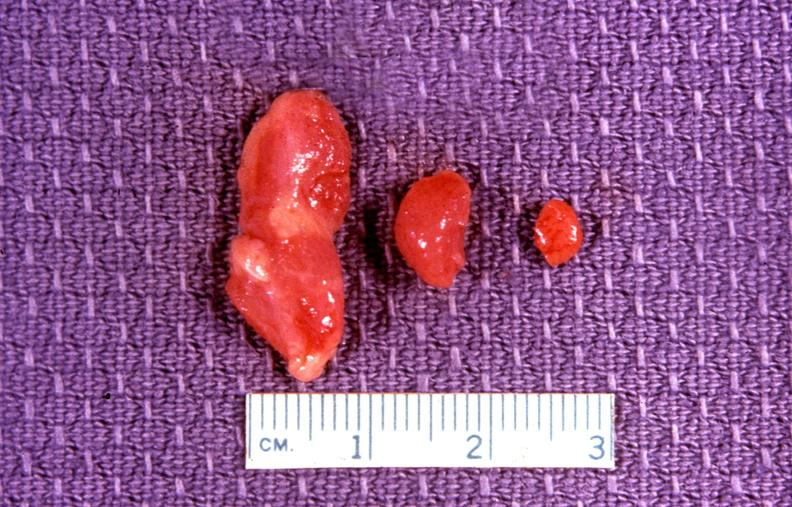does another fiber other frame show parathyroid, adenoma?
Answer the question using a single word or phrase. No 